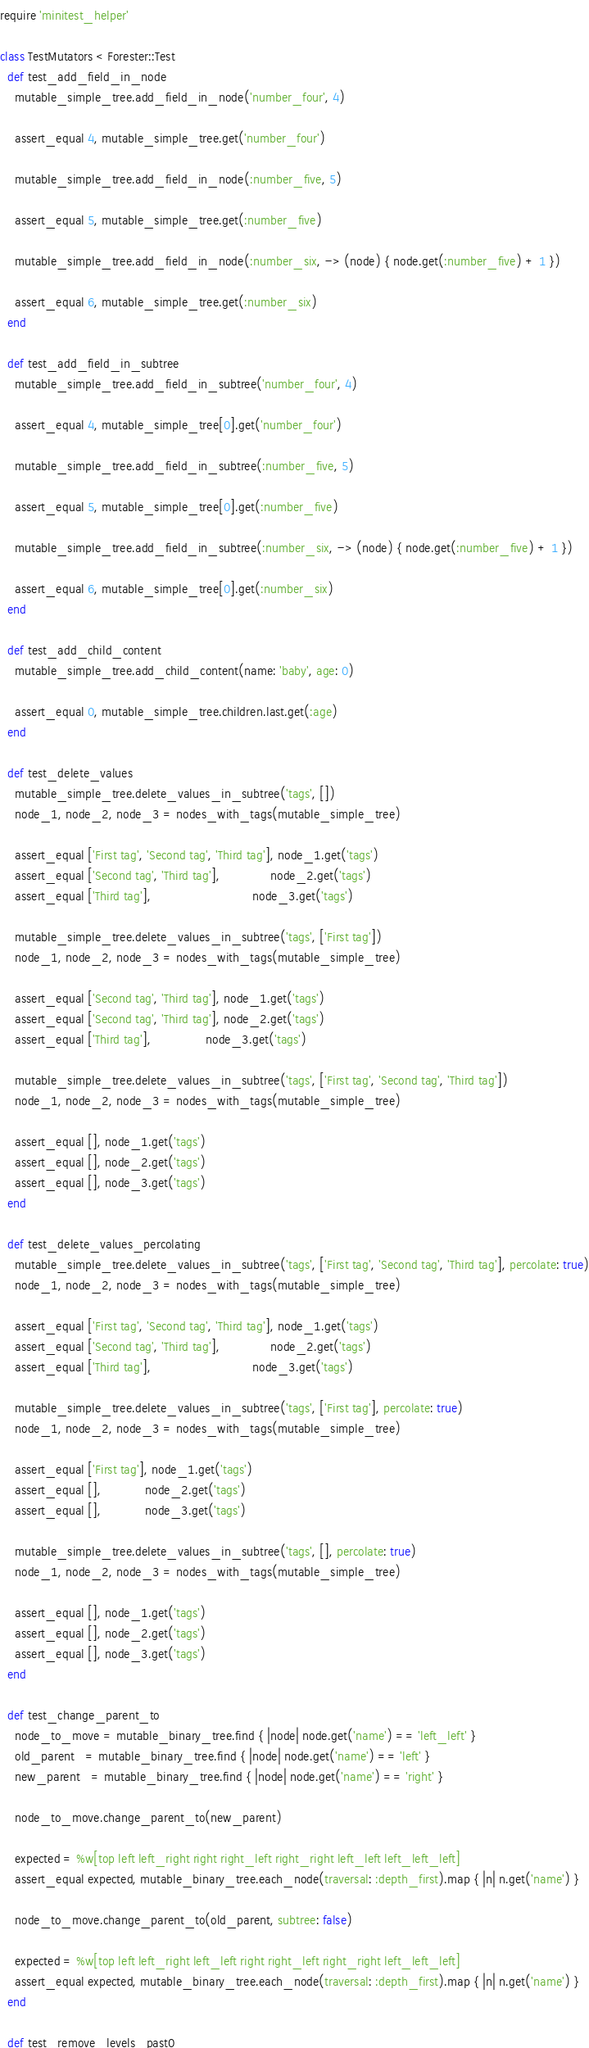Convert code to text. <code><loc_0><loc_0><loc_500><loc_500><_Ruby_>require 'minitest_helper'

class TestMutators < Forester::Test
  def test_add_field_in_node
    mutable_simple_tree.add_field_in_node('number_four', 4)

    assert_equal 4, mutable_simple_tree.get('number_four')

    mutable_simple_tree.add_field_in_node(:number_five, 5)

    assert_equal 5, mutable_simple_tree.get(:number_five)

    mutable_simple_tree.add_field_in_node(:number_six, -> (node) { node.get(:number_five) + 1 })

    assert_equal 6, mutable_simple_tree.get(:number_six)
  end

  def test_add_field_in_subtree
    mutable_simple_tree.add_field_in_subtree('number_four', 4)

    assert_equal 4, mutable_simple_tree[0].get('number_four')

    mutable_simple_tree.add_field_in_subtree(:number_five, 5)

    assert_equal 5, mutable_simple_tree[0].get(:number_five)

    mutable_simple_tree.add_field_in_subtree(:number_six, -> (node) { node.get(:number_five) + 1 })

    assert_equal 6, mutable_simple_tree[0].get(:number_six)
  end

  def test_add_child_content
    mutable_simple_tree.add_child_content(name: 'baby', age: 0)

    assert_equal 0, mutable_simple_tree.children.last.get(:age)
  end

  def test_delete_values
    mutable_simple_tree.delete_values_in_subtree('tags', [])
    node_1, node_2, node_3 = nodes_with_tags(mutable_simple_tree)

    assert_equal ['First tag', 'Second tag', 'Third tag'], node_1.get('tags')
    assert_equal ['Second tag', 'Third tag'],              node_2.get('tags')
    assert_equal ['Third tag'],                            node_3.get('tags')

    mutable_simple_tree.delete_values_in_subtree('tags', ['First tag'])
    node_1, node_2, node_3 = nodes_with_tags(mutable_simple_tree)

    assert_equal ['Second tag', 'Third tag'], node_1.get('tags')
    assert_equal ['Second tag', 'Third tag'], node_2.get('tags')
    assert_equal ['Third tag'],               node_3.get('tags')

    mutable_simple_tree.delete_values_in_subtree('tags', ['First tag', 'Second tag', 'Third tag'])
    node_1, node_2, node_3 = nodes_with_tags(mutable_simple_tree)

    assert_equal [], node_1.get('tags')
    assert_equal [], node_2.get('tags')
    assert_equal [], node_3.get('tags')
  end

  def test_delete_values_percolating
    mutable_simple_tree.delete_values_in_subtree('tags', ['First tag', 'Second tag', 'Third tag'], percolate: true)
    node_1, node_2, node_3 = nodes_with_tags(mutable_simple_tree)

    assert_equal ['First tag', 'Second tag', 'Third tag'], node_1.get('tags')
    assert_equal ['Second tag', 'Third tag'],              node_2.get('tags')
    assert_equal ['Third tag'],                            node_3.get('tags')

    mutable_simple_tree.delete_values_in_subtree('tags', ['First tag'], percolate: true)
    node_1, node_2, node_3 = nodes_with_tags(mutable_simple_tree)

    assert_equal ['First tag'], node_1.get('tags')
    assert_equal [],            node_2.get('tags')
    assert_equal [],            node_3.get('tags')

    mutable_simple_tree.delete_values_in_subtree('tags', [], percolate: true)
    node_1, node_2, node_3 = nodes_with_tags(mutable_simple_tree)

    assert_equal [], node_1.get('tags')
    assert_equal [], node_2.get('tags')
    assert_equal [], node_3.get('tags')
  end

  def test_change_parent_to
    node_to_move = mutable_binary_tree.find { |node| node.get('name') == 'left_left' }
    old_parent   = mutable_binary_tree.find { |node| node.get('name') == 'left' }
    new_parent   = mutable_binary_tree.find { |node| node.get('name') == 'right' }

    node_to_move.change_parent_to(new_parent)

    expected = %w[top left left_right right right_left right_right left_left left_left_left]
    assert_equal expected, mutable_binary_tree.each_node(traversal: :depth_first).map { |n| n.get('name') }

    node_to_move.change_parent_to(old_parent, subtree: false)

    expected = %w[top left left_right left_left right right_left right_right left_left_left]
    assert_equal expected, mutable_binary_tree.each_node(traversal: :depth_first).map { |n| n.get('name') }
  end

  def test_remove_levels_past0</code> 